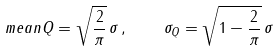<formula> <loc_0><loc_0><loc_500><loc_500>\ m e a n { Q } = \sqrt { \frac { 2 } { \pi } } \, \sigma \, , \quad \sigma _ { Q } = \sqrt { 1 - \frac { 2 } { \pi } } \, \sigma</formula> 